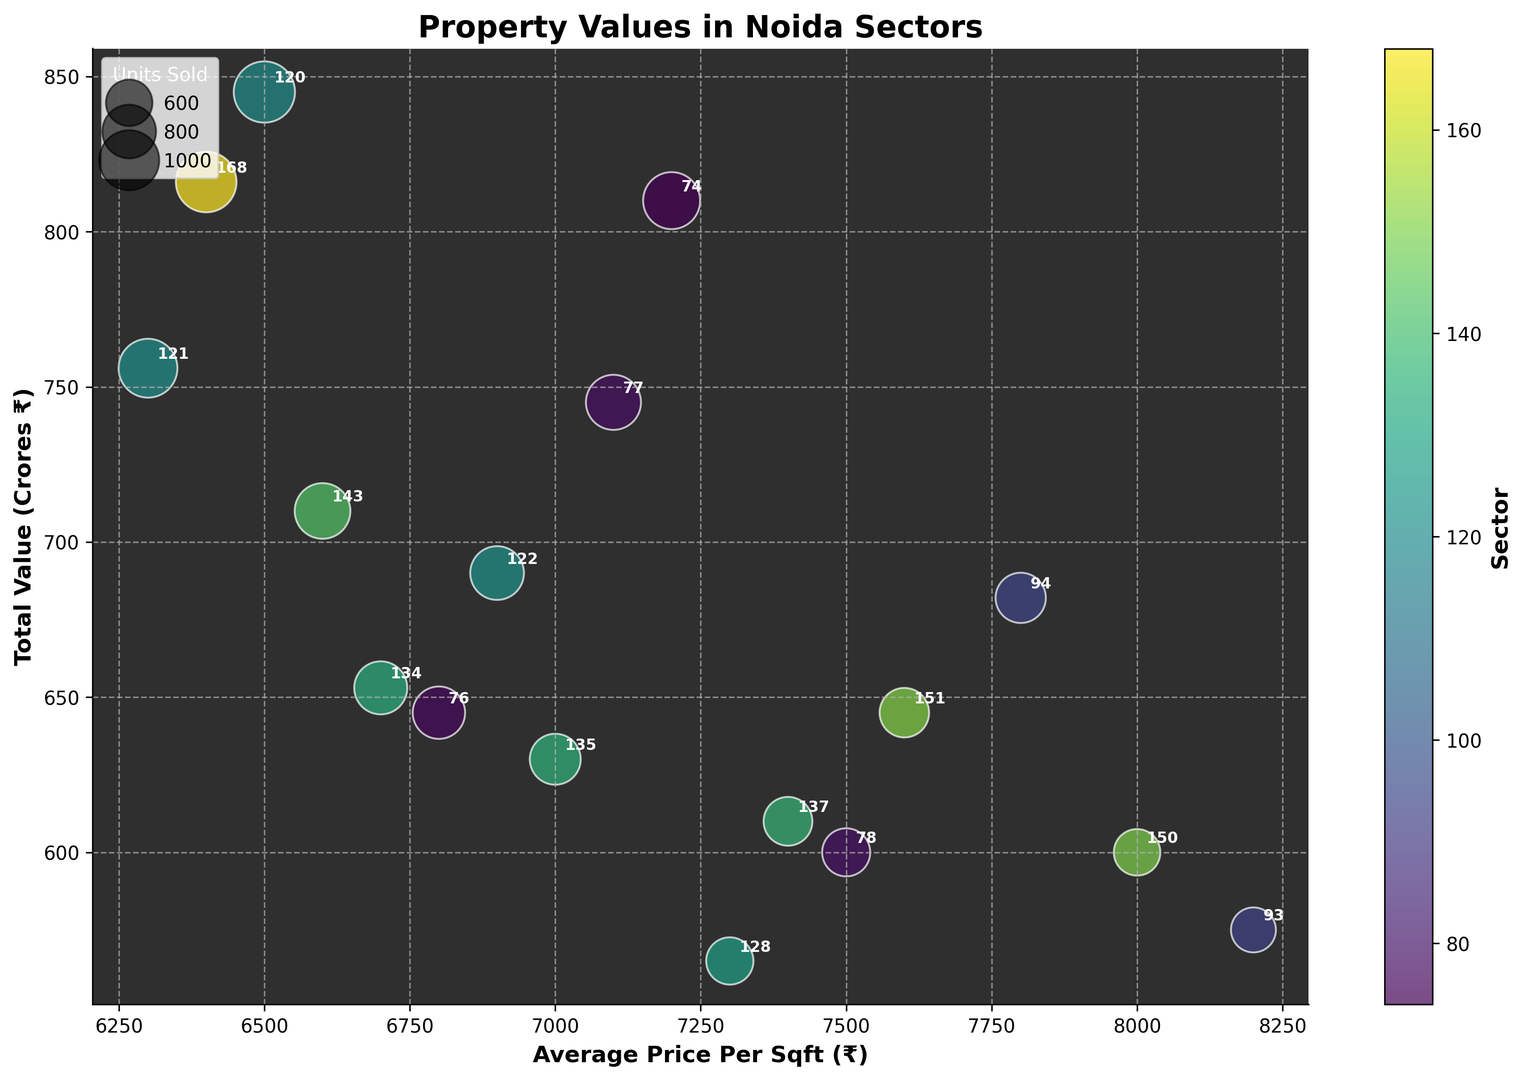What is the average price per sqft of the sector with the highest total value? First, look for the highest total value on the vertical (y-axis). The sector with the highest total value is Sector 74 with ₹810 Crores. Then, find the average price per sqft on the horizontal axis for this sector. It is ₹7200.
Answer: ₹7200 Which sector has the most units sold? The bubble chart uses bubble size to represent the number of units sold. The largest bubble corresponds to the sector with the highest units sold. Sector 120 has the largest bubble with 520 units sold.
Answer: Sector 120 Which sector has the lowest average price per sqft? Scan the x-axis for the lowest value of average price per sqft. The lowest value is ₹6300 for Sector 121.
Answer: Sector 121 Which sector has a higher average price per sqft: Sector 93 or Sector 150? Compare the positions of Sectors 93 and 150 on the x-axis. Sector 93 has an average price per sqft of ₹8200, while Sector 150 has ₹8000. Since ₹8200 is greater than ₹8000, Sector 93 has a higher average price per sqft.
Answer: Sector 93 What is the total value difference between Sector 78 and Sector 128? Find the total value of each sector on the y-axis. Sector 78 has ₹600 Crores, and Sector 128 has ₹565 Crores. The difference is
Answer: ₹600 - ₹565 = ₹35 Crores Which sector has the highest total value among those with an average price per sqft of above ₹7000? Identify sectors with average prices per sqft above ₹7000 and compare their total values. Sectors with average prices above ₹7000 are Sectors 74, 77, 78, 93, 94, 135, 137, 150, and 151. Among these, Sector 74 has the highest total value at ₹810 Crores.
Answer: Sector 74 How many sectors have an average price per sqft below ₹7000? Count the number of sectors with average prices below ₹7000 by examining the x-axis. These sectors are Sectors 76, 120, 121, 134, 143, and 168. There are 6 such sectors.
Answer: 6 Which sector has the smallest bubble with an average price per sqft above ₹7500? Identify sectors with an average price above ₹7500 on the x-axis and examine the bubble sizes for each. The smallest bubble among these is Sector 93 with 280 units sold.
Answer: Sector 93 Which has a higher total value, Sector 121 or Sector 134? Compare the y-axis values for Sectors 121 and 134. Sector 121 has a total value of ₹756 Crores, whereas Sector 134 has ₹653 Crores. Therefore, Sector 121 has a higher total value.
Answer: Sector 121 